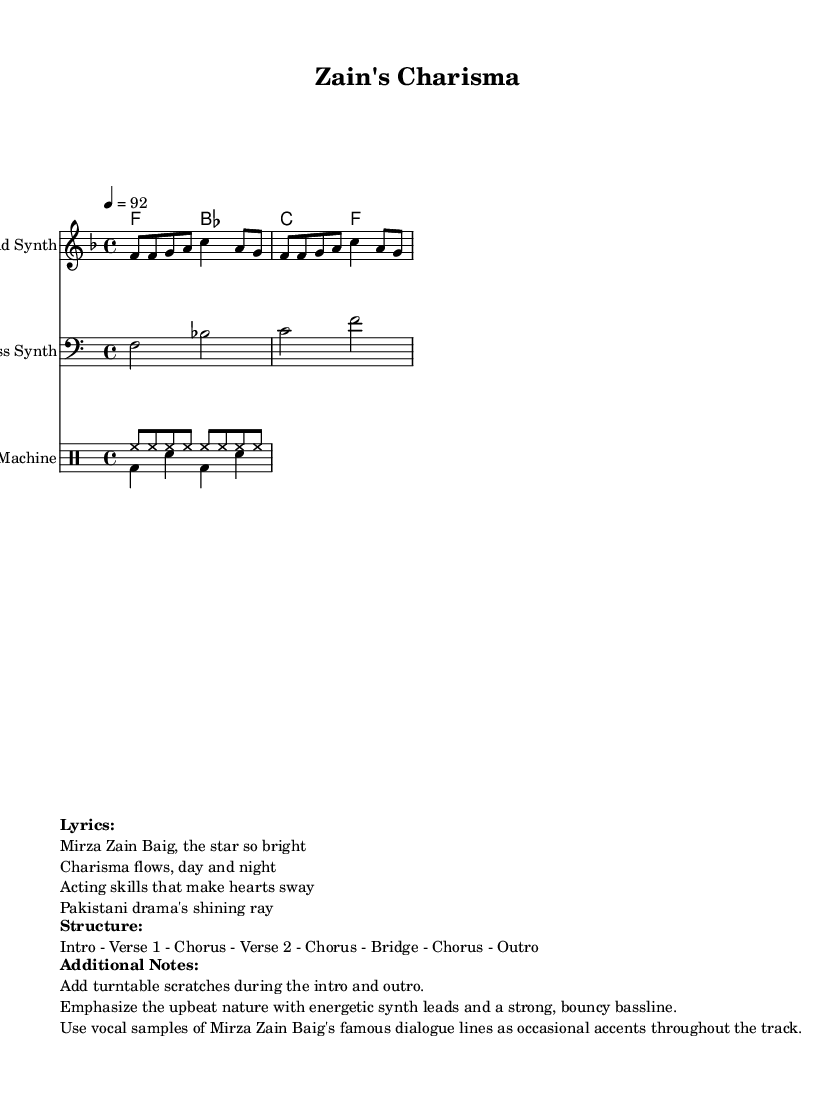What is the key signature of this music? The key signature is F major, which has one flat (B flat). It can be identified by looking at the beginning of the staff where the sharps and flats are noted.
Answer: F major What is the time signature of this music? The time signature is 4/4, which indicates four beats per measure. This can be found in the notation at the beginning, where it specifies how the measures are grouped.
Answer: 4/4 What is the tempo of this piece? The tempo is 92 beats per minute, indicated by the marking at the beginning of the music which shows the speed at which the piece should be played.
Answer: 92 How many sections are indicated in the structure? The structure of the music consists of seven sections: Intro, Verse 1, Chorus, Verse 2, Chorus, Bridge, and Outro. This is noted in the markup section labeled "Structure."
Answer: Seven What type of instruments are used in this score? The instruments used in this score are Lead Synth, Bass Synth, and Drum Machine, as specified in the instrument names for each staff in the score.
Answer: Lead Synth, Bass Synth, Drum Machine What unique elements are added during the intro and outro? Turntable scratches are added during both the intro and outro, which is a common feature in rap music to enhance the energetic feel. This information is outlined in the "Additional Notes" section.
Answer: Turntable scratches What vocal elements are incorporated throughout the track? Vocal samples of Mirza Zain Baig's famous dialogue lines are used as accents throughout the track, adding a unique and personal touch that connects to the artist's persona. This is mentioned in the "Additional Notes."
Answer: Vocal samples 